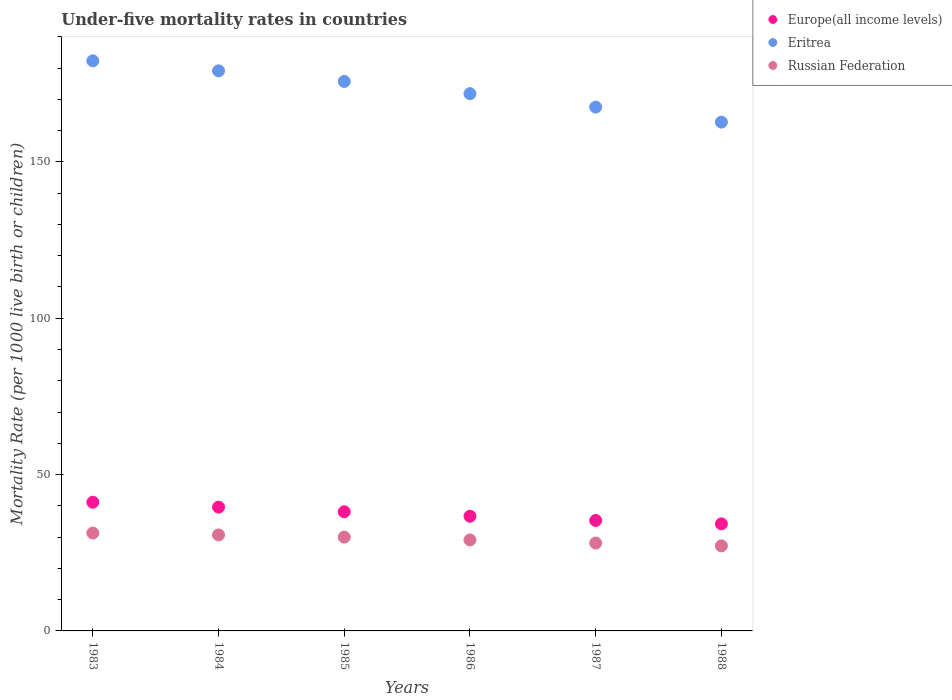How many different coloured dotlines are there?
Offer a very short reply. 3. What is the under-five mortality rate in Europe(all income levels) in 1988?
Keep it short and to the point. 34.24. Across all years, what is the maximum under-five mortality rate in Russian Federation?
Your answer should be compact. 31.3. Across all years, what is the minimum under-five mortality rate in Europe(all income levels)?
Your answer should be very brief. 34.24. In which year was the under-five mortality rate in Russian Federation maximum?
Provide a succinct answer. 1983. In which year was the under-five mortality rate in Europe(all income levels) minimum?
Your answer should be compact. 1988. What is the total under-five mortality rate in Russian Federation in the graph?
Make the answer very short. 176.4. What is the difference between the under-five mortality rate in Europe(all income levels) in 1983 and that in 1987?
Give a very brief answer. 5.83. What is the difference between the under-five mortality rate in Russian Federation in 1988 and the under-five mortality rate in Eritrea in 1987?
Your response must be concise. -140.3. What is the average under-five mortality rate in Russian Federation per year?
Give a very brief answer. 29.4. In the year 1988, what is the difference between the under-five mortality rate in Russian Federation and under-five mortality rate in Europe(all income levels)?
Offer a terse response. -7.04. In how many years, is the under-five mortality rate in Russian Federation greater than 110?
Give a very brief answer. 0. What is the ratio of the under-five mortality rate in Russian Federation in 1983 to that in 1986?
Your answer should be very brief. 1.08. Is the under-five mortality rate in Europe(all income levels) in 1984 less than that in 1988?
Provide a succinct answer. No. Is the difference between the under-five mortality rate in Russian Federation in 1984 and 1985 greater than the difference between the under-five mortality rate in Europe(all income levels) in 1984 and 1985?
Offer a terse response. No. What is the difference between the highest and the second highest under-five mortality rate in Russian Federation?
Offer a very short reply. 0.6. What is the difference between the highest and the lowest under-five mortality rate in Europe(all income levels)?
Ensure brevity in your answer.  6.91. Is it the case that in every year, the sum of the under-five mortality rate in Europe(all income levels) and under-five mortality rate in Eritrea  is greater than the under-five mortality rate in Russian Federation?
Provide a short and direct response. Yes. Is the under-five mortality rate in Russian Federation strictly less than the under-five mortality rate in Eritrea over the years?
Your answer should be compact. Yes. Does the graph contain any zero values?
Provide a succinct answer. No. Where does the legend appear in the graph?
Ensure brevity in your answer.  Top right. What is the title of the graph?
Ensure brevity in your answer.  Under-five mortality rates in countries. What is the label or title of the X-axis?
Keep it short and to the point. Years. What is the label or title of the Y-axis?
Your response must be concise. Mortality Rate (per 1000 live birth or children). What is the Mortality Rate (per 1000 live birth or children) in Europe(all income levels) in 1983?
Give a very brief answer. 41.15. What is the Mortality Rate (per 1000 live birth or children) of Eritrea in 1983?
Your response must be concise. 182.3. What is the Mortality Rate (per 1000 live birth or children) in Russian Federation in 1983?
Provide a succinct answer. 31.3. What is the Mortality Rate (per 1000 live birth or children) of Europe(all income levels) in 1984?
Your response must be concise. 39.59. What is the Mortality Rate (per 1000 live birth or children) in Eritrea in 1984?
Your response must be concise. 179.1. What is the Mortality Rate (per 1000 live birth or children) of Russian Federation in 1984?
Provide a succinct answer. 30.7. What is the Mortality Rate (per 1000 live birth or children) in Europe(all income levels) in 1985?
Your answer should be compact. 38.11. What is the Mortality Rate (per 1000 live birth or children) in Eritrea in 1985?
Offer a terse response. 175.7. What is the Mortality Rate (per 1000 live birth or children) in Europe(all income levels) in 1986?
Ensure brevity in your answer.  36.67. What is the Mortality Rate (per 1000 live birth or children) of Eritrea in 1986?
Your response must be concise. 171.8. What is the Mortality Rate (per 1000 live birth or children) of Russian Federation in 1986?
Make the answer very short. 29.1. What is the Mortality Rate (per 1000 live birth or children) of Europe(all income levels) in 1987?
Give a very brief answer. 35.32. What is the Mortality Rate (per 1000 live birth or children) of Eritrea in 1987?
Make the answer very short. 167.5. What is the Mortality Rate (per 1000 live birth or children) of Russian Federation in 1987?
Make the answer very short. 28.1. What is the Mortality Rate (per 1000 live birth or children) in Europe(all income levels) in 1988?
Your answer should be very brief. 34.24. What is the Mortality Rate (per 1000 live birth or children) in Eritrea in 1988?
Offer a terse response. 162.7. What is the Mortality Rate (per 1000 live birth or children) of Russian Federation in 1988?
Keep it short and to the point. 27.2. Across all years, what is the maximum Mortality Rate (per 1000 live birth or children) in Europe(all income levels)?
Give a very brief answer. 41.15. Across all years, what is the maximum Mortality Rate (per 1000 live birth or children) in Eritrea?
Offer a terse response. 182.3. Across all years, what is the maximum Mortality Rate (per 1000 live birth or children) of Russian Federation?
Make the answer very short. 31.3. Across all years, what is the minimum Mortality Rate (per 1000 live birth or children) in Europe(all income levels)?
Keep it short and to the point. 34.24. Across all years, what is the minimum Mortality Rate (per 1000 live birth or children) of Eritrea?
Offer a very short reply. 162.7. Across all years, what is the minimum Mortality Rate (per 1000 live birth or children) in Russian Federation?
Provide a succinct answer. 27.2. What is the total Mortality Rate (per 1000 live birth or children) in Europe(all income levels) in the graph?
Make the answer very short. 225.07. What is the total Mortality Rate (per 1000 live birth or children) of Eritrea in the graph?
Make the answer very short. 1039.1. What is the total Mortality Rate (per 1000 live birth or children) of Russian Federation in the graph?
Make the answer very short. 176.4. What is the difference between the Mortality Rate (per 1000 live birth or children) in Europe(all income levels) in 1983 and that in 1984?
Provide a short and direct response. 1.56. What is the difference between the Mortality Rate (per 1000 live birth or children) in Russian Federation in 1983 and that in 1984?
Your answer should be very brief. 0.6. What is the difference between the Mortality Rate (per 1000 live birth or children) of Europe(all income levels) in 1983 and that in 1985?
Your answer should be very brief. 3.04. What is the difference between the Mortality Rate (per 1000 live birth or children) in Eritrea in 1983 and that in 1985?
Provide a short and direct response. 6.6. What is the difference between the Mortality Rate (per 1000 live birth or children) in Europe(all income levels) in 1983 and that in 1986?
Your answer should be very brief. 4.48. What is the difference between the Mortality Rate (per 1000 live birth or children) of Russian Federation in 1983 and that in 1986?
Keep it short and to the point. 2.2. What is the difference between the Mortality Rate (per 1000 live birth or children) of Europe(all income levels) in 1983 and that in 1987?
Make the answer very short. 5.83. What is the difference between the Mortality Rate (per 1000 live birth or children) in Eritrea in 1983 and that in 1987?
Offer a terse response. 14.8. What is the difference between the Mortality Rate (per 1000 live birth or children) in Russian Federation in 1983 and that in 1987?
Ensure brevity in your answer.  3.2. What is the difference between the Mortality Rate (per 1000 live birth or children) in Europe(all income levels) in 1983 and that in 1988?
Your answer should be compact. 6.91. What is the difference between the Mortality Rate (per 1000 live birth or children) in Eritrea in 1983 and that in 1988?
Your answer should be compact. 19.6. What is the difference between the Mortality Rate (per 1000 live birth or children) of Russian Federation in 1983 and that in 1988?
Give a very brief answer. 4.1. What is the difference between the Mortality Rate (per 1000 live birth or children) of Europe(all income levels) in 1984 and that in 1985?
Make the answer very short. 1.48. What is the difference between the Mortality Rate (per 1000 live birth or children) in Europe(all income levels) in 1984 and that in 1986?
Your answer should be very brief. 2.92. What is the difference between the Mortality Rate (per 1000 live birth or children) of Eritrea in 1984 and that in 1986?
Offer a very short reply. 7.3. What is the difference between the Mortality Rate (per 1000 live birth or children) in Europe(all income levels) in 1984 and that in 1987?
Provide a short and direct response. 4.27. What is the difference between the Mortality Rate (per 1000 live birth or children) in Eritrea in 1984 and that in 1987?
Give a very brief answer. 11.6. What is the difference between the Mortality Rate (per 1000 live birth or children) of Russian Federation in 1984 and that in 1987?
Your answer should be very brief. 2.6. What is the difference between the Mortality Rate (per 1000 live birth or children) in Europe(all income levels) in 1984 and that in 1988?
Provide a short and direct response. 5.35. What is the difference between the Mortality Rate (per 1000 live birth or children) in Russian Federation in 1984 and that in 1988?
Offer a very short reply. 3.5. What is the difference between the Mortality Rate (per 1000 live birth or children) of Europe(all income levels) in 1985 and that in 1986?
Offer a terse response. 1.44. What is the difference between the Mortality Rate (per 1000 live birth or children) of Eritrea in 1985 and that in 1986?
Make the answer very short. 3.9. What is the difference between the Mortality Rate (per 1000 live birth or children) of Russian Federation in 1985 and that in 1986?
Ensure brevity in your answer.  0.9. What is the difference between the Mortality Rate (per 1000 live birth or children) in Europe(all income levels) in 1985 and that in 1987?
Your answer should be compact. 2.79. What is the difference between the Mortality Rate (per 1000 live birth or children) of Eritrea in 1985 and that in 1987?
Your answer should be compact. 8.2. What is the difference between the Mortality Rate (per 1000 live birth or children) in Europe(all income levels) in 1985 and that in 1988?
Your answer should be very brief. 3.87. What is the difference between the Mortality Rate (per 1000 live birth or children) in Eritrea in 1985 and that in 1988?
Give a very brief answer. 13. What is the difference between the Mortality Rate (per 1000 live birth or children) of Russian Federation in 1985 and that in 1988?
Give a very brief answer. 2.8. What is the difference between the Mortality Rate (per 1000 live birth or children) of Europe(all income levels) in 1986 and that in 1987?
Provide a succinct answer. 1.36. What is the difference between the Mortality Rate (per 1000 live birth or children) of Europe(all income levels) in 1986 and that in 1988?
Provide a short and direct response. 2.43. What is the difference between the Mortality Rate (per 1000 live birth or children) of Eritrea in 1986 and that in 1988?
Offer a terse response. 9.1. What is the difference between the Mortality Rate (per 1000 live birth or children) of Europe(all income levels) in 1987 and that in 1988?
Your answer should be compact. 1.08. What is the difference between the Mortality Rate (per 1000 live birth or children) in Eritrea in 1987 and that in 1988?
Ensure brevity in your answer.  4.8. What is the difference between the Mortality Rate (per 1000 live birth or children) of Russian Federation in 1987 and that in 1988?
Your response must be concise. 0.9. What is the difference between the Mortality Rate (per 1000 live birth or children) in Europe(all income levels) in 1983 and the Mortality Rate (per 1000 live birth or children) in Eritrea in 1984?
Give a very brief answer. -137.95. What is the difference between the Mortality Rate (per 1000 live birth or children) in Europe(all income levels) in 1983 and the Mortality Rate (per 1000 live birth or children) in Russian Federation in 1984?
Make the answer very short. 10.45. What is the difference between the Mortality Rate (per 1000 live birth or children) in Eritrea in 1983 and the Mortality Rate (per 1000 live birth or children) in Russian Federation in 1984?
Your response must be concise. 151.6. What is the difference between the Mortality Rate (per 1000 live birth or children) of Europe(all income levels) in 1983 and the Mortality Rate (per 1000 live birth or children) of Eritrea in 1985?
Ensure brevity in your answer.  -134.55. What is the difference between the Mortality Rate (per 1000 live birth or children) in Europe(all income levels) in 1983 and the Mortality Rate (per 1000 live birth or children) in Russian Federation in 1985?
Offer a terse response. 11.15. What is the difference between the Mortality Rate (per 1000 live birth or children) of Eritrea in 1983 and the Mortality Rate (per 1000 live birth or children) of Russian Federation in 1985?
Your response must be concise. 152.3. What is the difference between the Mortality Rate (per 1000 live birth or children) of Europe(all income levels) in 1983 and the Mortality Rate (per 1000 live birth or children) of Eritrea in 1986?
Keep it short and to the point. -130.65. What is the difference between the Mortality Rate (per 1000 live birth or children) in Europe(all income levels) in 1983 and the Mortality Rate (per 1000 live birth or children) in Russian Federation in 1986?
Provide a succinct answer. 12.05. What is the difference between the Mortality Rate (per 1000 live birth or children) of Eritrea in 1983 and the Mortality Rate (per 1000 live birth or children) of Russian Federation in 1986?
Offer a very short reply. 153.2. What is the difference between the Mortality Rate (per 1000 live birth or children) in Europe(all income levels) in 1983 and the Mortality Rate (per 1000 live birth or children) in Eritrea in 1987?
Provide a short and direct response. -126.35. What is the difference between the Mortality Rate (per 1000 live birth or children) of Europe(all income levels) in 1983 and the Mortality Rate (per 1000 live birth or children) of Russian Federation in 1987?
Keep it short and to the point. 13.05. What is the difference between the Mortality Rate (per 1000 live birth or children) in Eritrea in 1983 and the Mortality Rate (per 1000 live birth or children) in Russian Federation in 1987?
Your response must be concise. 154.2. What is the difference between the Mortality Rate (per 1000 live birth or children) in Europe(all income levels) in 1983 and the Mortality Rate (per 1000 live birth or children) in Eritrea in 1988?
Give a very brief answer. -121.55. What is the difference between the Mortality Rate (per 1000 live birth or children) of Europe(all income levels) in 1983 and the Mortality Rate (per 1000 live birth or children) of Russian Federation in 1988?
Make the answer very short. 13.95. What is the difference between the Mortality Rate (per 1000 live birth or children) of Eritrea in 1983 and the Mortality Rate (per 1000 live birth or children) of Russian Federation in 1988?
Provide a succinct answer. 155.1. What is the difference between the Mortality Rate (per 1000 live birth or children) in Europe(all income levels) in 1984 and the Mortality Rate (per 1000 live birth or children) in Eritrea in 1985?
Ensure brevity in your answer.  -136.11. What is the difference between the Mortality Rate (per 1000 live birth or children) of Europe(all income levels) in 1984 and the Mortality Rate (per 1000 live birth or children) of Russian Federation in 1985?
Make the answer very short. 9.59. What is the difference between the Mortality Rate (per 1000 live birth or children) of Eritrea in 1984 and the Mortality Rate (per 1000 live birth or children) of Russian Federation in 1985?
Your response must be concise. 149.1. What is the difference between the Mortality Rate (per 1000 live birth or children) in Europe(all income levels) in 1984 and the Mortality Rate (per 1000 live birth or children) in Eritrea in 1986?
Your response must be concise. -132.21. What is the difference between the Mortality Rate (per 1000 live birth or children) in Europe(all income levels) in 1984 and the Mortality Rate (per 1000 live birth or children) in Russian Federation in 1986?
Make the answer very short. 10.49. What is the difference between the Mortality Rate (per 1000 live birth or children) in Eritrea in 1984 and the Mortality Rate (per 1000 live birth or children) in Russian Federation in 1986?
Provide a succinct answer. 150. What is the difference between the Mortality Rate (per 1000 live birth or children) of Europe(all income levels) in 1984 and the Mortality Rate (per 1000 live birth or children) of Eritrea in 1987?
Offer a terse response. -127.91. What is the difference between the Mortality Rate (per 1000 live birth or children) in Europe(all income levels) in 1984 and the Mortality Rate (per 1000 live birth or children) in Russian Federation in 1987?
Keep it short and to the point. 11.49. What is the difference between the Mortality Rate (per 1000 live birth or children) of Eritrea in 1984 and the Mortality Rate (per 1000 live birth or children) of Russian Federation in 1987?
Ensure brevity in your answer.  151. What is the difference between the Mortality Rate (per 1000 live birth or children) in Europe(all income levels) in 1984 and the Mortality Rate (per 1000 live birth or children) in Eritrea in 1988?
Provide a short and direct response. -123.11. What is the difference between the Mortality Rate (per 1000 live birth or children) of Europe(all income levels) in 1984 and the Mortality Rate (per 1000 live birth or children) of Russian Federation in 1988?
Your response must be concise. 12.39. What is the difference between the Mortality Rate (per 1000 live birth or children) in Eritrea in 1984 and the Mortality Rate (per 1000 live birth or children) in Russian Federation in 1988?
Offer a terse response. 151.9. What is the difference between the Mortality Rate (per 1000 live birth or children) in Europe(all income levels) in 1985 and the Mortality Rate (per 1000 live birth or children) in Eritrea in 1986?
Offer a very short reply. -133.69. What is the difference between the Mortality Rate (per 1000 live birth or children) in Europe(all income levels) in 1985 and the Mortality Rate (per 1000 live birth or children) in Russian Federation in 1986?
Offer a very short reply. 9.01. What is the difference between the Mortality Rate (per 1000 live birth or children) in Eritrea in 1985 and the Mortality Rate (per 1000 live birth or children) in Russian Federation in 1986?
Your answer should be compact. 146.6. What is the difference between the Mortality Rate (per 1000 live birth or children) in Europe(all income levels) in 1985 and the Mortality Rate (per 1000 live birth or children) in Eritrea in 1987?
Give a very brief answer. -129.39. What is the difference between the Mortality Rate (per 1000 live birth or children) in Europe(all income levels) in 1985 and the Mortality Rate (per 1000 live birth or children) in Russian Federation in 1987?
Your response must be concise. 10.01. What is the difference between the Mortality Rate (per 1000 live birth or children) of Eritrea in 1985 and the Mortality Rate (per 1000 live birth or children) of Russian Federation in 1987?
Offer a terse response. 147.6. What is the difference between the Mortality Rate (per 1000 live birth or children) of Europe(all income levels) in 1985 and the Mortality Rate (per 1000 live birth or children) of Eritrea in 1988?
Provide a succinct answer. -124.59. What is the difference between the Mortality Rate (per 1000 live birth or children) in Europe(all income levels) in 1985 and the Mortality Rate (per 1000 live birth or children) in Russian Federation in 1988?
Give a very brief answer. 10.91. What is the difference between the Mortality Rate (per 1000 live birth or children) of Eritrea in 1985 and the Mortality Rate (per 1000 live birth or children) of Russian Federation in 1988?
Your response must be concise. 148.5. What is the difference between the Mortality Rate (per 1000 live birth or children) of Europe(all income levels) in 1986 and the Mortality Rate (per 1000 live birth or children) of Eritrea in 1987?
Offer a terse response. -130.83. What is the difference between the Mortality Rate (per 1000 live birth or children) in Europe(all income levels) in 1986 and the Mortality Rate (per 1000 live birth or children) in Russian Federation in 1987?
Give a very brief answer. 8.57. What is the difference between the Mortality Rate (per 1000 live birth or children) of Eritrea in 1986 and the Mortality Rate (per 1000 live birth or children) of Russian Federation in 1987?
Offer a very short reply. 143.7. What is the difference between the Mortality Rate (per 1000 live birth or children) in Europe(all income levels) in 1986 and the Mortality Rate (per 1000 live birth or children) in Eritrea in 1988?
Keep it short and to the point. -126.03. What is the difference between the Mortality Rate (per 1000 live birth or children) in Europe(all income levels) in 1986 and the Mortality Rate (per 1000 live birth or children) in Russian Federation in 1988?
Offer a terse response. 9.47. What is the difference between the Mortality Rate (per 1000 live birth or children) of Eritrea in 1986 and the Mortality Rate (per 1000 live birth or children) of Russian Federation in 1988?
Provide a succinct answer. 144.6. What is the difference between the Mortality Rate (per 1000 live birth or children) in Europe(all income levels) in 1987 and the Mortality Rate (per 1000 live birth or children) in Eritrea in 1988?
Keep it short and to the point. -127.38. What is the difference between the Mortality Rate (per 1000 live birth or children) of Europe(all income levels) in 1987 and the Mortality Rate (per 1000 live birth or children) of Russian Federation in 1988?
Give a very brief answer. 8.12. What is the difference between the Mortality Rate (per 1000 live birth or children) in Eritrea in 1987 and the Mortality Rate (per 1000 live birth or children) in Russian Federation in 1988?
Offer a terse response. 140.3. What is the average Mortality Rate (per 1000 live birth or children) in Europe(all income levels) per year?
Your answer should be very brief. 37.51. What is the average Mortality Rate (per 1000 live birth or children) in Eritrea per year?
Ensure brevity in your answer.  173.18. What is the average Mortality Rate (per 1000 live birth or children) of Russian Federation per year?
Offer a very short reply. 29.4. In the year 1983, what is the difference between the Mortality Rate (per 1000 live birth or children) of Europe(all income levels) and Mortality Rate (per 1000 live birth or children) of Eritrea?
Make the answer very short. -141.15. In the year 1983, what is the difference between the Mortality Rate (per 1000 live birth or children) of Europe(all income levels) and Mortality Rate (per 1000 live birth or children) of Russian Federation?
Ensure brevity in your answer.  9.85. In the year 1983, what is the difference between the Mortality Rate (per 1000 live birth or children) of Eritrea and Mortality Rate (per 1000 live birth or children) of Russian Federation?
Offer a terse response. 151. In the year 1984, what is the difference between the Mortality Rate (per 1000 live birth or children) of Europe(all income levels) and Mortality Rate (per 1000 live birth or children) of Eritrea?
Make the answer very short. -139.51. In the year 1984, what is the difference between the Mortality Rate (per 1000 live birth or children) of Europe(all income levels) and Mortality Rate (per 1000 live birth or children) of Russian Federation?
Make the answer very short. 8.89. In the year 1984, what is the difference between the Mortality Rate (per 1000 live birth or children) of Eritrea and Mortality Rate (per 1000 live birth or children) of Russian Federation?
Keep it short and to the point. 148.4. In the year 1985, what is the difference between the Mortality Rate (per 1000 live birth or children) in Europe(all income levels) and Mortality Rate (per 1000 live birth or children) in Eritrea?
Make the answer very short. -137.59. In the year 1985, what is the difference between the Mortality Rate (per 1000 live birth or children) of Europe(all income levels) and Mortality Rate (per 1000 live birth or children) of Russian Federation?
Provide a short and direct response. 8.11. In the year 1985, what is the difference between the Mortality Rate (per 1000 live birth or children) in Eritrea and Mortality Rate (per 1000 live birth or children) in Russian Federation?
Provide a short and direct response. 145.7. In the year 1986, what is the difference between the Mortality Rate (per 1000 live birth or children) in Europe(all income levels) and Mortality Rate (per 1000 live birth or children) in Eritrea?
Make the answer very short. -135.13. In the year 1986, what is the difference between the Mortality Rate (per 1000 live birth or children) of Europe(all income levels) and Mortality Rate (per 1000 live birth or children) of Russian Federation?
Provide a succinct answer. 7.57. In the year 1986, what is the difference between the Mortality Rate (per 1000 live birth or children) of Eritrea and Mortality Rate (per 1000 live birth or children) of Russian Federation?
Make the answer very short. 142.7. In the year 1987, what is the difference between the Mortality Rate (per 1000 live birth or children) in Europe(all income levels) and Mortality Rate (per 1000 live birth or children) in Eritrea?
Make the answer very short. -132.18. In the year 1987, what is the difference between the Mortality Rate (per 1000 live birth or children) in Europe(all income levels) and Mortality Rate (per 1000 live birth or children) in Russian Federation?
Keep it short and to the point. 7.22. In the year 1987, what is the difference between the Mortality Rate (per 1000 live birth or children) in Eritrea and Mortality Rate (per 1000 live birth or children) in Russian Federation?
Make the answer very short. 139.4. In the year 1988, what is the difference between the Mortality Rate (per 1000 live birth or children) in Europe(all income levels) and Mortality Rate (per 1000 live birth or children) in Eritrea?
Offer a terse response. -128.46. In the year 1988, what is the difference between the Mortality Rate (per 1000 live birth or children) in Europe(all income levels) and Mortality Rate (per 1000 live birth or children) in Russian Federation?
Provide a succinct answer. 7.04. In the year 1988, what is the difference between the Mortality Rate (per 1000 live birth or children) of Eritrea and Mortality Rate (per 1000 live birth or children) of Russian Federation?
Your answer should be very brief. 135.5. What is the ratio of the Mortality Rate (per 1000 live birth or children) of Europe(all income levels) in 1983 to that in 1984?
Offer a terse response. 1.04. What is the ratio of the Mortality Rate (per 1000 live birth or children) in Eritrea in 1983 to that in 1984?
Ensure brevity in your answer.  1.02. What is the ratio of the Mortality Rate (per 1000 live birth or children) in Russian Federation in 1983 to that in 1984?
Keep it short and to the point. 1.02. What is the ratio of the Mortality Rate (per 1000 live birth or children) in Europe(all income levels) in 1983 to that in 1985?
Make the answer very short. 1.08. What is the ratio of the Mortality Rate (per 1000 live birth or children) of Eritrea in 1983 to that in 1985?
Provide a succinct answer. 1.04. What is the ratio of the Mortality Rate (per 1000 live birth or children) of Russian Federation in 1983 to that in 1985?
Make the answer very short. 1.04. What is the ratio of the Mortality Rate (per 1000 live birth or children) of Europe(all income levels) in 1983 to that in 1986?
Offer a very short reply. 1.12. What is the ratio of the Mortality Rate (per 1000 live birth or children) of Eritrea in 1983 to that in 1986?
Ensure brevity in your answer.  1.06. What is the ratio of the Mortality Rate (per 1000 live birth or children) of Russian Federation in 1983 to that in 1986?
Ensure brevity in your answer.  1.08. What is the ratio of the Mortality Rate (per 1000 live birth or children) of Europe(all income levels) in 1983 to that in 1987?
Make the answer very short. 1.17. What is the ratio of the Mortality Rate (per 1000 live birth or children) of Eritrea in 1983 to that in 1987?
Provide a short and direct response. 1.09. What is the ratio of the Mortality Rate (per 1000 live birth or children) in Russian Federation in 1983 to that in 1987?
Your response must be concise. 1.11. What is the ratio of the Mortality Rate (per 1000 live birth or children) in Europe(all income levels) in 1983 to that in 1988?
Provide a succinct answer. 1.2. What is the ratio of the Mortality Rate (per 1000 live birth or children) of Eritrea in 1983 to that in 1988?
Provide a succinct answer. 1.12. What is the ratio of the Mortality Rate (per 1000 live birth or children) of Russian Federation in 1983 to that in 1988?
Your response must be concise. 1.15. What is the ratio of the Mortality Rate (per 1000 live birth or children) of Europe(all income levels) in 1984 to that in 1985?
Keep it short and to the point. 1.04. What is the ratio of the Mortality Rate (per 1000 live birth or children) of Eritrea in 1984 to that in 1985?
Offer a terse response. 1.02. What is the ratio of the Mortality Rate (per 1000 live birth or children) in Russian Federation in 1984 to that in 1985?
Provide a succinct answer. 1.02. What is the ratio of the Mortality Rate (per 1000 live birth or children) of Europe(all income levels) in 1984 to that in 1986?
Provide a short and direct response. 1.08. What is the ratio of the Mortality Rate (per 1000 live birth or children) in Eritrea in 1984 to that in 1986?
Make the answer very short. 1.04. What is the ratio of the Mortality Rate (per 1000 live birth or children) of Russian Federation in 1984 to that in 1986?
Give a very brief answer. 1.05. What is the ratio of the Mortality Rate (per 1000 live birth or children) in Europe(all income levels) in 1984 to that in 1987?
Give a very brief answer. 1.12. What is the ratio of the Mortality Rate (per 1000 live birth or children) in Eritrea in 1984 to that in 1987?
Your answer should be compact. 1.07. What is the ratio of the Mortality Rate (per 1000 live birth or children) in Russian Federation in 1984 to that in 1987?
Give a very brief answer. 1.09. What is the ratio of the Mortality Rate (per 1000 live birth or children) in Europe(all income levels) in 1984 to that in 1988?
Ensure brevity in your answer.  1.16. What is the ratio of the Mortality Rate (per 1000 live birth or children) of Eritrea in 1984 to that in 1988?
Your answer should be very brief. 1.1. What is the ratio of the Mortality Rate (per 1000 live birth or children) of Russian Federation in 1984 to that in 1988?
Give a very brief answer. 1.13. What is the ratio of the Mortality Rate (per 1000 live birth or children) of Europe(all income levels) in 1985 to that in 1986?
Your answer should be compact. 1.04. What is the ratio of the Mortality Rate (per 1000 live birth or children) of Eritrea in 1985 to that in 1986?
Offer a terse response. 1.02. What is the ratio of the Mortality Rate (per 1000 live birth or children) of Russian Federation in 1985 to that in 1986?
Keep it short and to the point. 1.03. What is the ratio of the Mortality Rate (per 1000 live birth or children) of Europe(all income levels) in 1985 to that in 1987?
Ensure brevity in your answer.  1.08. What is the ratio of the Mortality Rate (per 1000 live birth or children) in Eritrea in 1985 to that in 1987?
Give a very brief answer. 1.05. What is the ratio of the Mortality Rate (per 1000 live birth or children) of Russian Federation in 1985 to that in 1987?
Keep it short and to the point. 1.07. What is the ratio of the Mortality Rate (per 1000 live birth or children) of Europe(all income levels) in 1985 to that in 1988?
Provide a succinct answer. 1.11. What is the ratio of the Mortality Rate (per 1000 live birth or children) in Eritrea in 1985 to that in 1988?
Your answer should be compact. 1.08. What is the ratio of the Mortality Rate (per 1000 live birth or children) of Russian Federation in 1985 to that in 1988?
Give a very brief answer. 1.1. What is the ratio of the Mortality Rate (per 1000 live birth or children) of Europe(all income levels) in 1986 to that in 1987?
Provide a short and direct response. 1.04. What is the ratio of the Mortality Rate (per 1000 live birth or children) in Eritrea in 1986 to that in 1987?
Make the answer very short. 1.03. What is the ratio of the Mortality Rate (per 1000 live birth or children) of Russian Federation in 1986 to that in 1987?
Give a very brief answer. 1.04. What is the ratio of the Mortality Rate (per 1000 live birth or children) in Europe(all income levels) in 1986 to that in 1988?
Your answer should be compact. 1.07. What is the ratio of the Mortality Rate (per 1000 live birth or children) in Eritrea in 1986 to that in 1988?
Provide a succinct answer. 1.06. What is the ratio of the Mortality Rate (per 1000 live birth or children) of Russian Federation in 1986 to that in 1988?
Your answer should be compact. 1.07. What is the ratio of the Mortality Rate (per 1000 live birth or children) of Europe(all income levels) in 1987 to that in 1988?
Ensure brevity in your answer.  1.03. What is the ratio of the Mortality Rate (per 1000 live birth or children) in Eritrea in 1987 to that in 1988?
Offer a terse response. 1.03. What is the ratio of the Mortality Rate (per 1000 live birth or children) of Russian Federation in 1987 to that in 1988?
Keep it short and to the point. 1.03. What is the difference between the highest and the second highest Mortality Rate (per 1000 live birth or children) of Europe(all income levels)?
Make the answer very short. 1.56. What is the difference between the highest and the second highest Mortality Rate (per 1000 live birth or children) in Eritrea?
Make the answer very short. 3.2. What is the difference between the highest and the second highest Mortality Rate (per 1000 live birth or children) of Russian Federation?
Ensure brevity in your answer.  0.6. What is the difference between the highest and the lowest Mortality Rate (per 1000 live birth or children) of Europe(all income levels)?
Offer a terse response. 6.91. What is the difference between the highest and the lowest Mortality Rate (per 1000 live birth or children) of Eritrea?
Your response must be concise. 19.6. What is the difference between the highest and the lowest Mortality Rate (per 1000 live birth or children) of Russian Federation?
Offer a terse response. 4.1. 